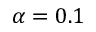<formula> <loc_0><loc_0><loc_500><loc_500>\alpha = 0 . 1</formula> 